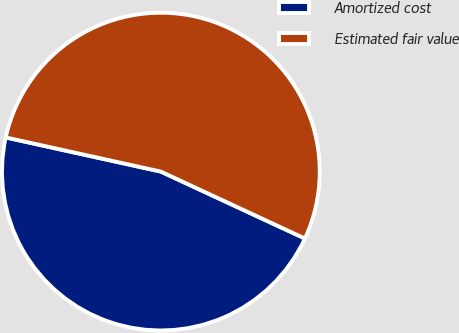Convert chart. <chart><loc_0><loc_0><loc_500><loc_500><pie_chart><fcel>Amortized cost<fcel>Estimated fair value<nl><fcel>46.53%<fcel>53.47%<nl></chart> 